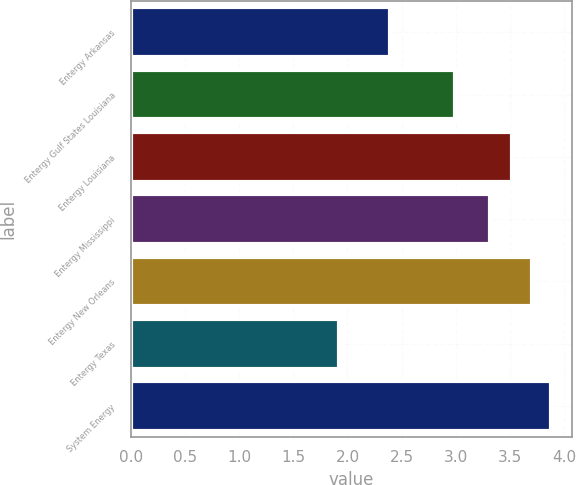Convert chart to OTSL. <chart><loc_0><loc_0><loc_500><loc_500><bar_chart><fcel>Entergy Arkansas<fcel>Entergy Gulf States Louisiana<fcel>Entergy Louisiana<fcel>Entergy Mississippi<fcel>Entergy New Orleans<fcel>Entergy Texas<fcel>System Energy<nl><fcel>2.39<fcel>2.99<fcel>3.52<fcel>3.31<fcel>3.7<fcel>1.92<fcel>3.88<nl></chart> 